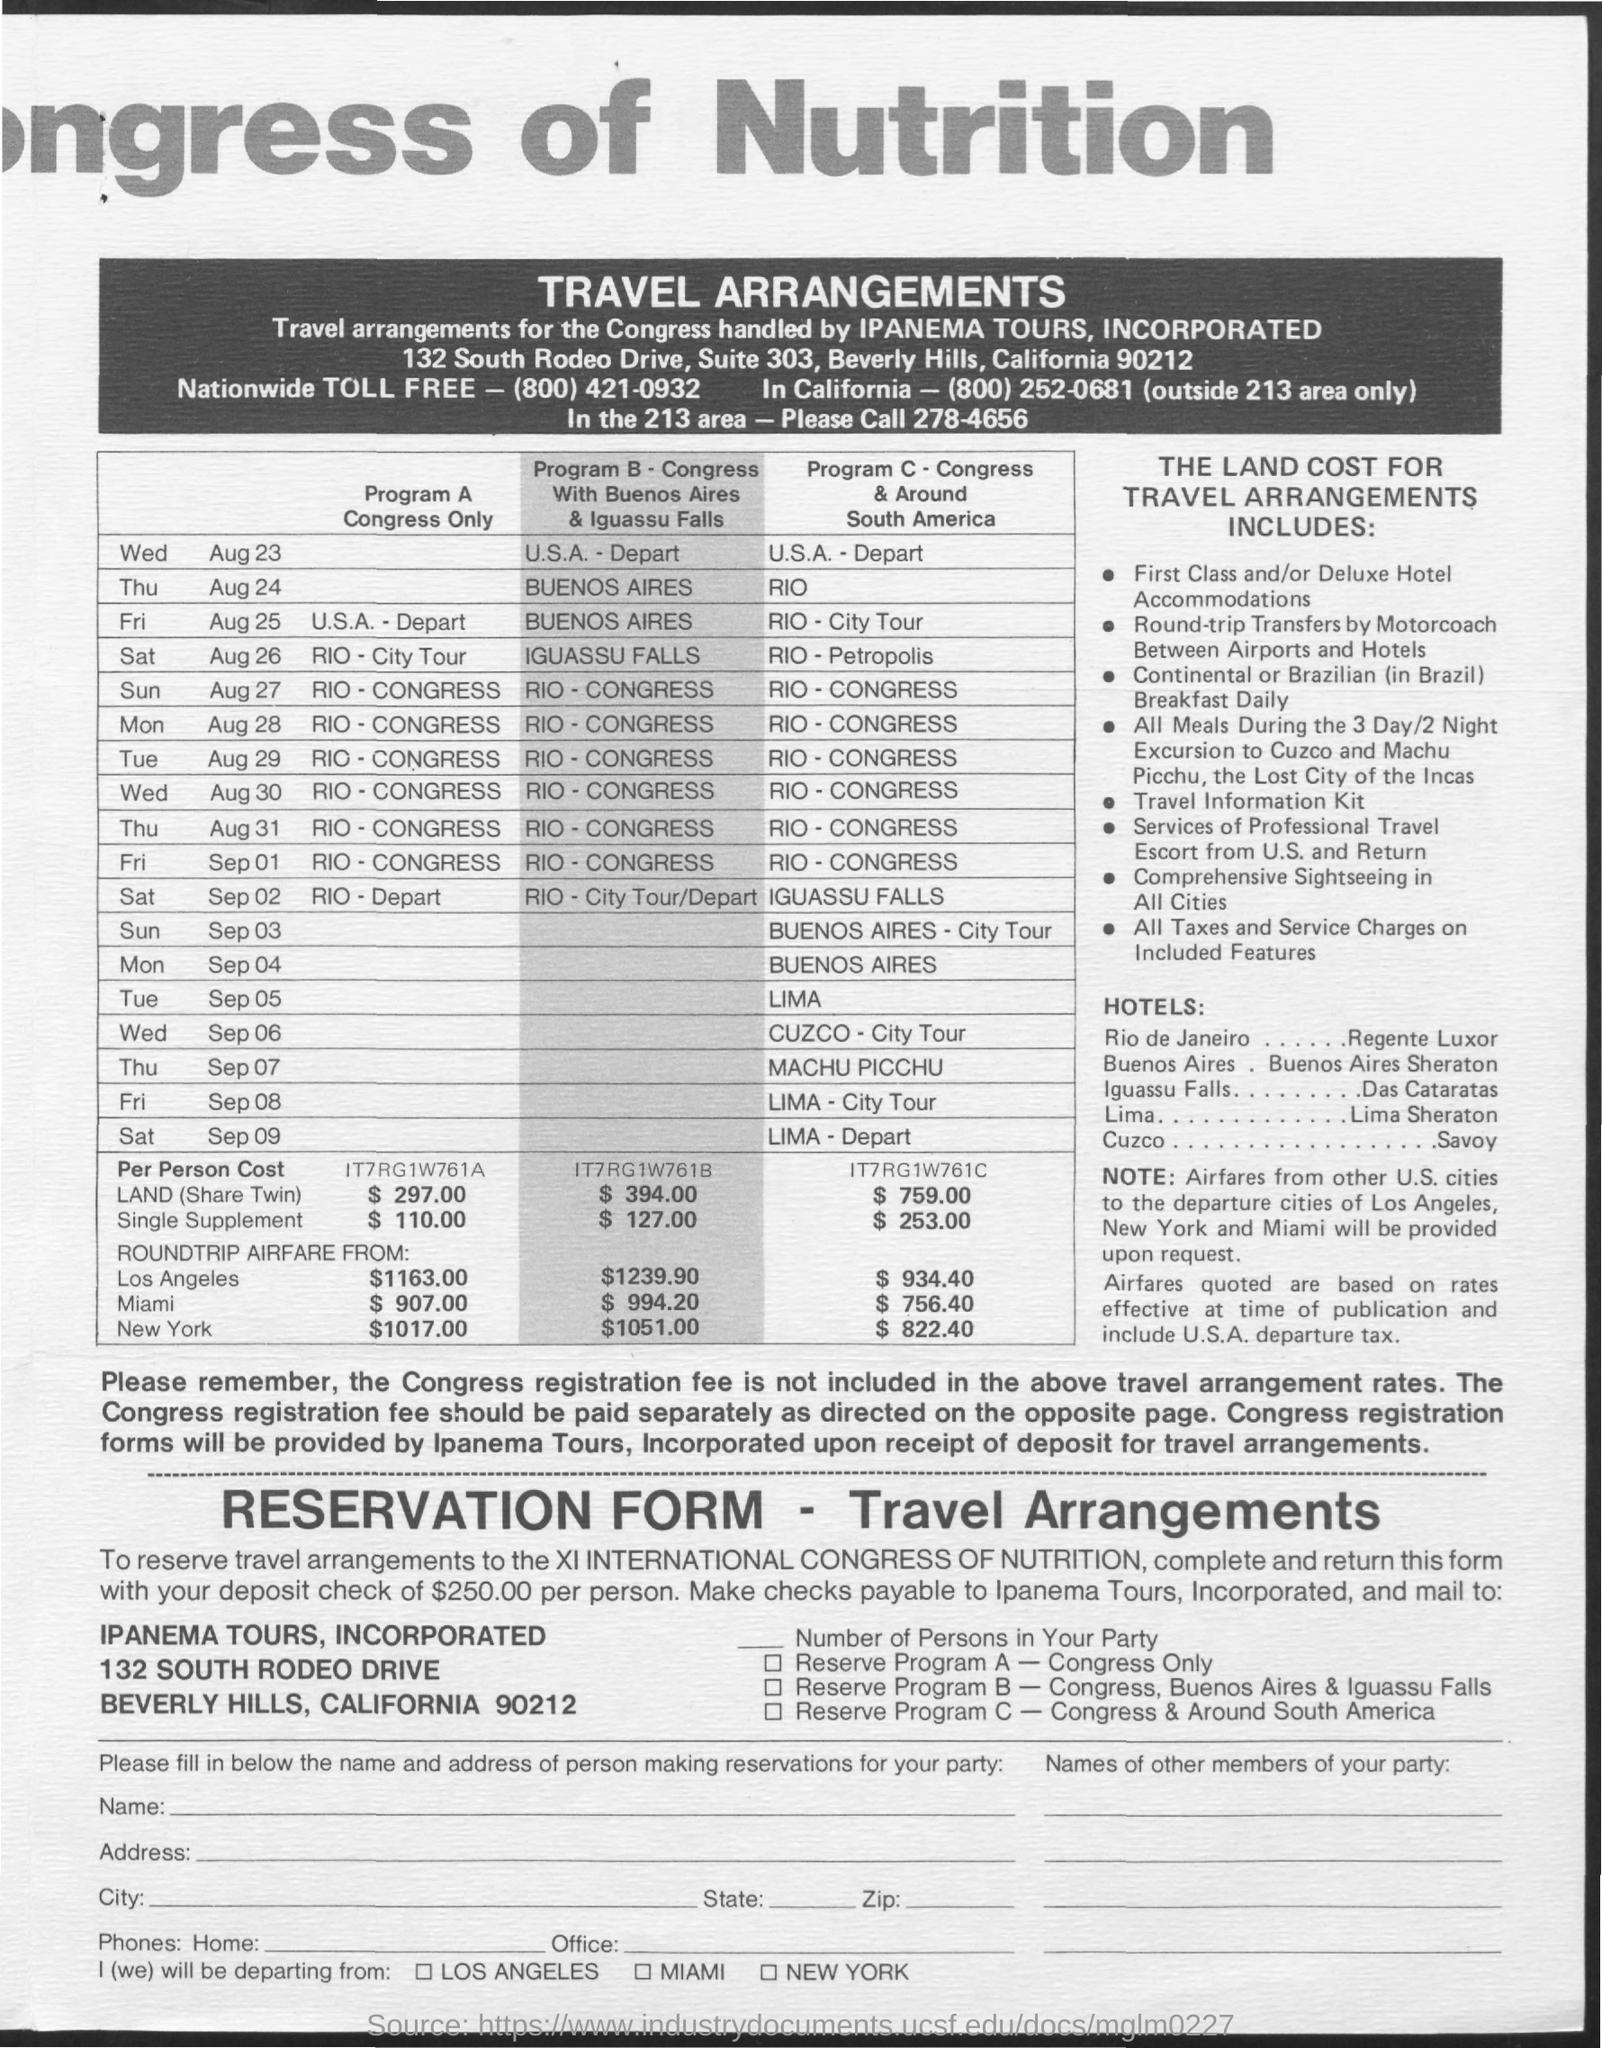What is the Nationwide Toll Free Number?
Your response must be concise. (800) 421-0932. 